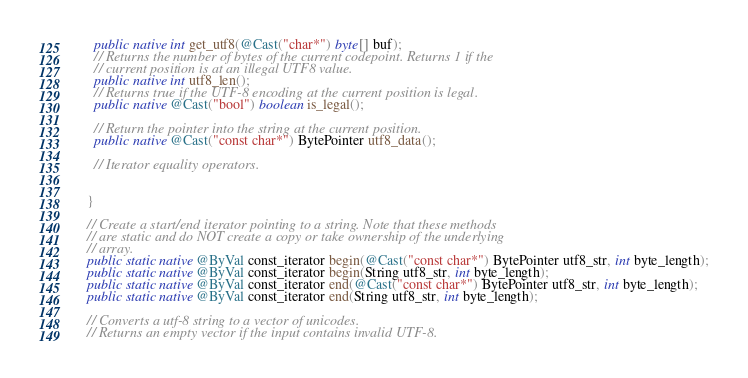<code> <loc_0><loc_0><loc_500><loc_500><_Java_>    public native int get_utf8(@Cast("char*") byte[] buf);
    // Returns the number of bytes of the current codepoint. Returns 1 if the
    // current position is at an illegal UTF8 value.
    public native int utf8_len();
    // Returns true if the UTF-8 encoding at the current position is legal.
    public native @Cast("bool") boolean is_legal();

    // Return the pointer into the string at the current position.
    public native @Cast("const char*") BytePointer utf8_data();

    // Iterator equality operators.
    
    
  }

  // Create a start/end iterator pointing to a string. Note that these methods
  // are static and do NOT create a copy or take ownership of the underlying
  // array.
  public static native @ByVal const_iterator begin(@Cast("const char*") BytePointer utf8_str, int byte_length);
  public static native @ByVal const_iterator begin(String utf8_str, int byte_length);
  public static native @ByVal const_iterator end(@Cast("const char*") BytePointer utf8_str, int byte_length);
  public static native @ByVal const_iterator end(String utf8_str, int byte_length);

  // Converts a utf-8 string to a vector of unicodes.
  // Returns an empty vector if the input contains invalid UTF-8.</code> 